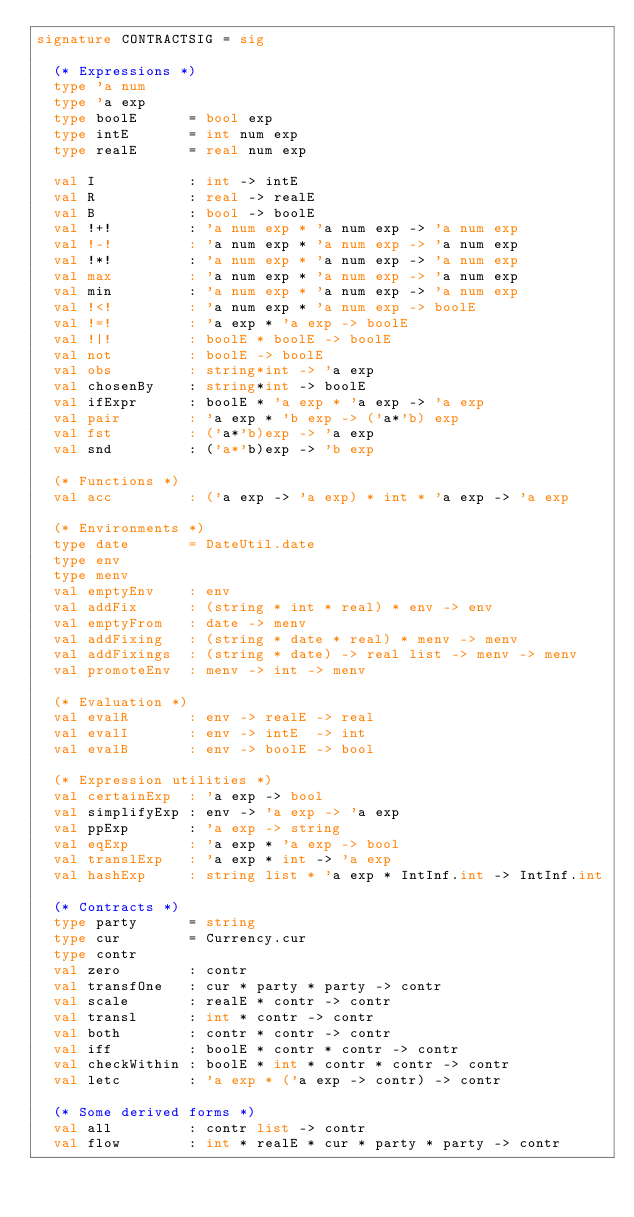<code> <loc_0><loc_0><loc_500><loc_500><_SML_>signature CONTRACTSIG = sig

  (* Expressions *)
  type 'a num
  type 'a exp
  type boolE      = bool exp
  type intE       = int num exp
  type realE      = real num exp

  val I           : int -> intE
  val R           : real -> realE
  val B           : bool -> boolE
  val !+!         : 'a num exp * 'a num exp -> 'a num exp
  val !-!         : 'a num exp * 'a num exp -> 'a num exp
  val !*!         : 'a num exp * 'a num exp -> 'a num exp
  val max         : 'a num exp * 'a num exp -> 'a num exp
  val min         : 'a num exp * 'a num exp -> 'a num exp
  val !<!         : 'a num exp * 'a num exp -> boolE
  val !=!         : 'a exp * 'a exp -> boolE
  val !|!         : boolE * boolE -> boolE
  val not         : boolE -> boolE
  val obs         : string*int -> 'a exp
  val chosenBy    : string*int -> boolE
  val ifExpr      : boolE * 'a exp * 'a exp -> 'a exp
  val pair        : 'a exp * 'b exp -> ('a*'b) exp
  val fst         : ('a*'b)exp -> 'a exp
  val snd         : ('a*'b)exp -> 'b exp

  (* Functions *)
  val acc         : ('a exp -> 'a exp) * int * 'a exp -> 'a exp

  (* Environments *)
  type date       = DateUtil.date
  type env
  type menv
  val emptyEnv    : env
  val addFix      : (string * int * real) * env -> env
  val emptyFrom   : date -> menv
  val addFixing   : (string * date * real) * menv -> menv
  val addFixings  : (string * date) -> real list -> menv -> menv
  val promoteEnv  : menv -> int -> menv

  (* Evaluation *)
  val evalR       : env -> realE -> real
  val evalI       : env -> intE  -> int
  val evalB       : env -> boolE -> bool

  (* Expression utilities *)
  val certainExp  : 'a exp -> bool
  val simplifyExp : env -> 'a exp -> 'a exp
  val ppExp       : 'a exp -> string
  val eqExp       : 'a exp * 'a exp -> bool
  val translExp   : 'a exp * int -> 'a exp
  val hashExp     : string list * 'a exp * IntInf.int -> IntInf.int

  (* Contracts *)
  type party      = string
  type cur        = Currency.cur
  type contr
  val zero        : contr
  val transfOne   : cur * party * party -> contr
  val scale       : realE * contr -> contr
  val transl      : int * contr -> contr
  val both        : contr * contr -> contr
  val iff         : boolE * contr * contr -> contr
  val checkWithin : boolE * int * contr * contr -> contr 
  val letc        : 'a exp * ('a exp -> contr) -> contr

  (* Some derived forms *)
  val all         : contr list -> contr
  val flow        : int * realE * cur * party * party -> contr</code> 